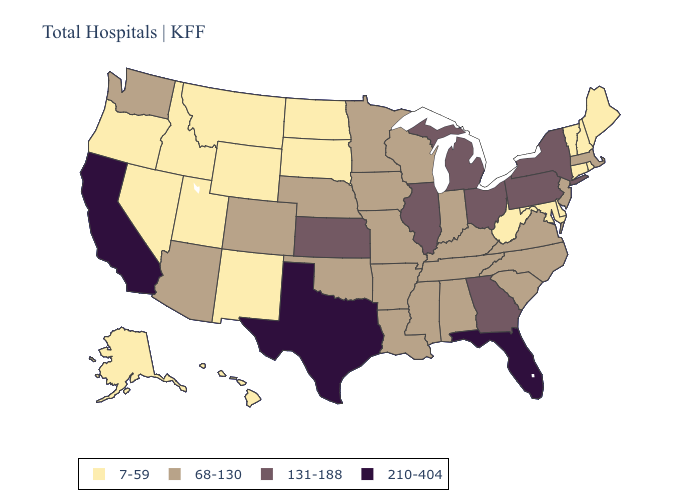Does Tennessee have the lowest value in the USA?
Keep it brief. No. Does South Carolina have the lowest value in the USA?
Be succinct. No. Does Massachusetts have a lower value than Nebraska?
Answer briefly. No. Does California have the highest value in the USA?
Be succinct. Yes. What is the value of Arizona?
Concise answer only. 68-130. Does Connecticut have the same value as Nevada?
Quick response, please. Yes. Name the states that have a value in the range 131-188?
Concise answer only. Georgia, Illinois, Kansas, Michigan, New York, Ohio, Pennsylvania. Which states have the highest value in the USA?
Concise answer only. California, Florida, Texas. How many symbols are there in the legend?
Short answer required. 4. What is the value of Arizona?
Write a very short answer. 68-130. Does New Mexico have the highest value in the West?
Keep it brief. No. Which states have the lowest value in the Northeast?
Write a very short answer. Connecticut, Maine, New Hampshire, Rhode Island, Vermont. Does Utah have the same value as Mississippi?
Give a very brief answer. No. Which states have the lowest value in the USA?
Be succinct. Alaska, Connecticut, Delaware, Hawaii, Idaho, Maine, Maryland, Montana, Nevada, New Hampshire, New Mexico, North Dakota, Oregon, Rhode Island, South Dakota, Utah, Vermont, West Virginia, Wyoming. Does Maryland have the lowest value in the South?
Give a very brief answer. Yes. 